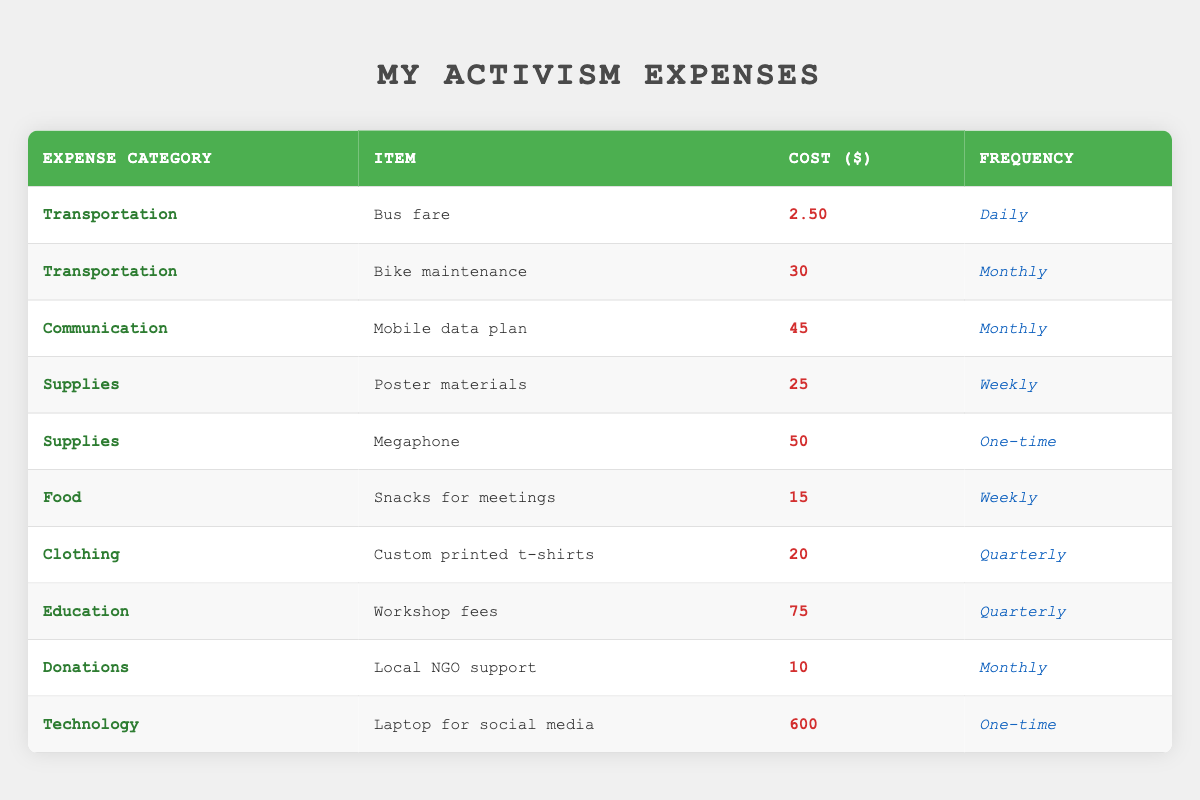What is the total cost for monthly communication expenses? There is one item listed under communication expenses, which is the mobile data plan. The cost is 45 dollars. Since this is the only monthly communication expense, the total is simply 45 dollars.
Answer: 45 How much do I spend on food for meetings weekly? There is one item under the food category for snacks for meetings, which costs 15 dollars per week. Therefore, the total weekly spending on food is 15 dollars.
Answer: 15 Which item has the highest cost? Analyzing the costs in the table, the item 'Laptop for social media' has the highest cost of 600 dollars, while the next highest are 'Bike maintenance' at 30 dollars and 'Workshop fees' at 75 dollars. Thus, the laptop is the most expensive item.
Answer: 600 What is the average cost of supplies per week? There are two supply items: 'Poster materials' costing 25 dollars weekly and 'Megaphone' costing 50 dollars as a one-time expense. Since we only consider the weekly expenses, we will take the 25 dollars and no additional value for one-time expenses. The average for supplies would be (25) / 1 = 25.
Answer: 25 Do I spend more on transportation or technology? For transportation, the costs are 2.50 dollars daily for bus fare and 30 dollars monthly for bike maintenance. Calculating bus fare for a month (assuming 30 days): 2.50 x 30 = 75. Therefore, total transportation expenses for the month is 75 + 30 = 105 dollars. The technology expense is a one-time cost of 600 dollars. Since 600 is greater than 105, I spend more on technology.
Answer: Yes How frequently do I spend on clothing? The only item in the clothing category is 'Custom printed t-shirts', which I purchase quarterly. This means I spend on clothing every three months.
Answer: Quarterly What is the combined total of monthly expenses? The monthly expenses include: mobile data plan (45), bike maintenance (30), and local NGO support (10). Adding these up: 45 + 30 + 10 = 85 dollars. Thus, the total monthly expenses amount to 85 dollars.
Answer: 85 Is there any one-time expense in the supplies category? The supplies category includes 'Poster materials' at 25 dollars weekly and 'Megaphone' which is a one-time expense costing 50 dollars. Therefore, yes, there is a one-time expense in the supplies category.
Answer: Yes What is my total expense on workshops per year? There is one workshop fee costing 75 dollars that occurs quarterly. To find the annual expense, multiply this quarterly cost by the number of quarters in a year (4): 75 x 4 = 300 dollars. Thus, my yearly expense on workshops is 300 dollars.
Answer: 300 